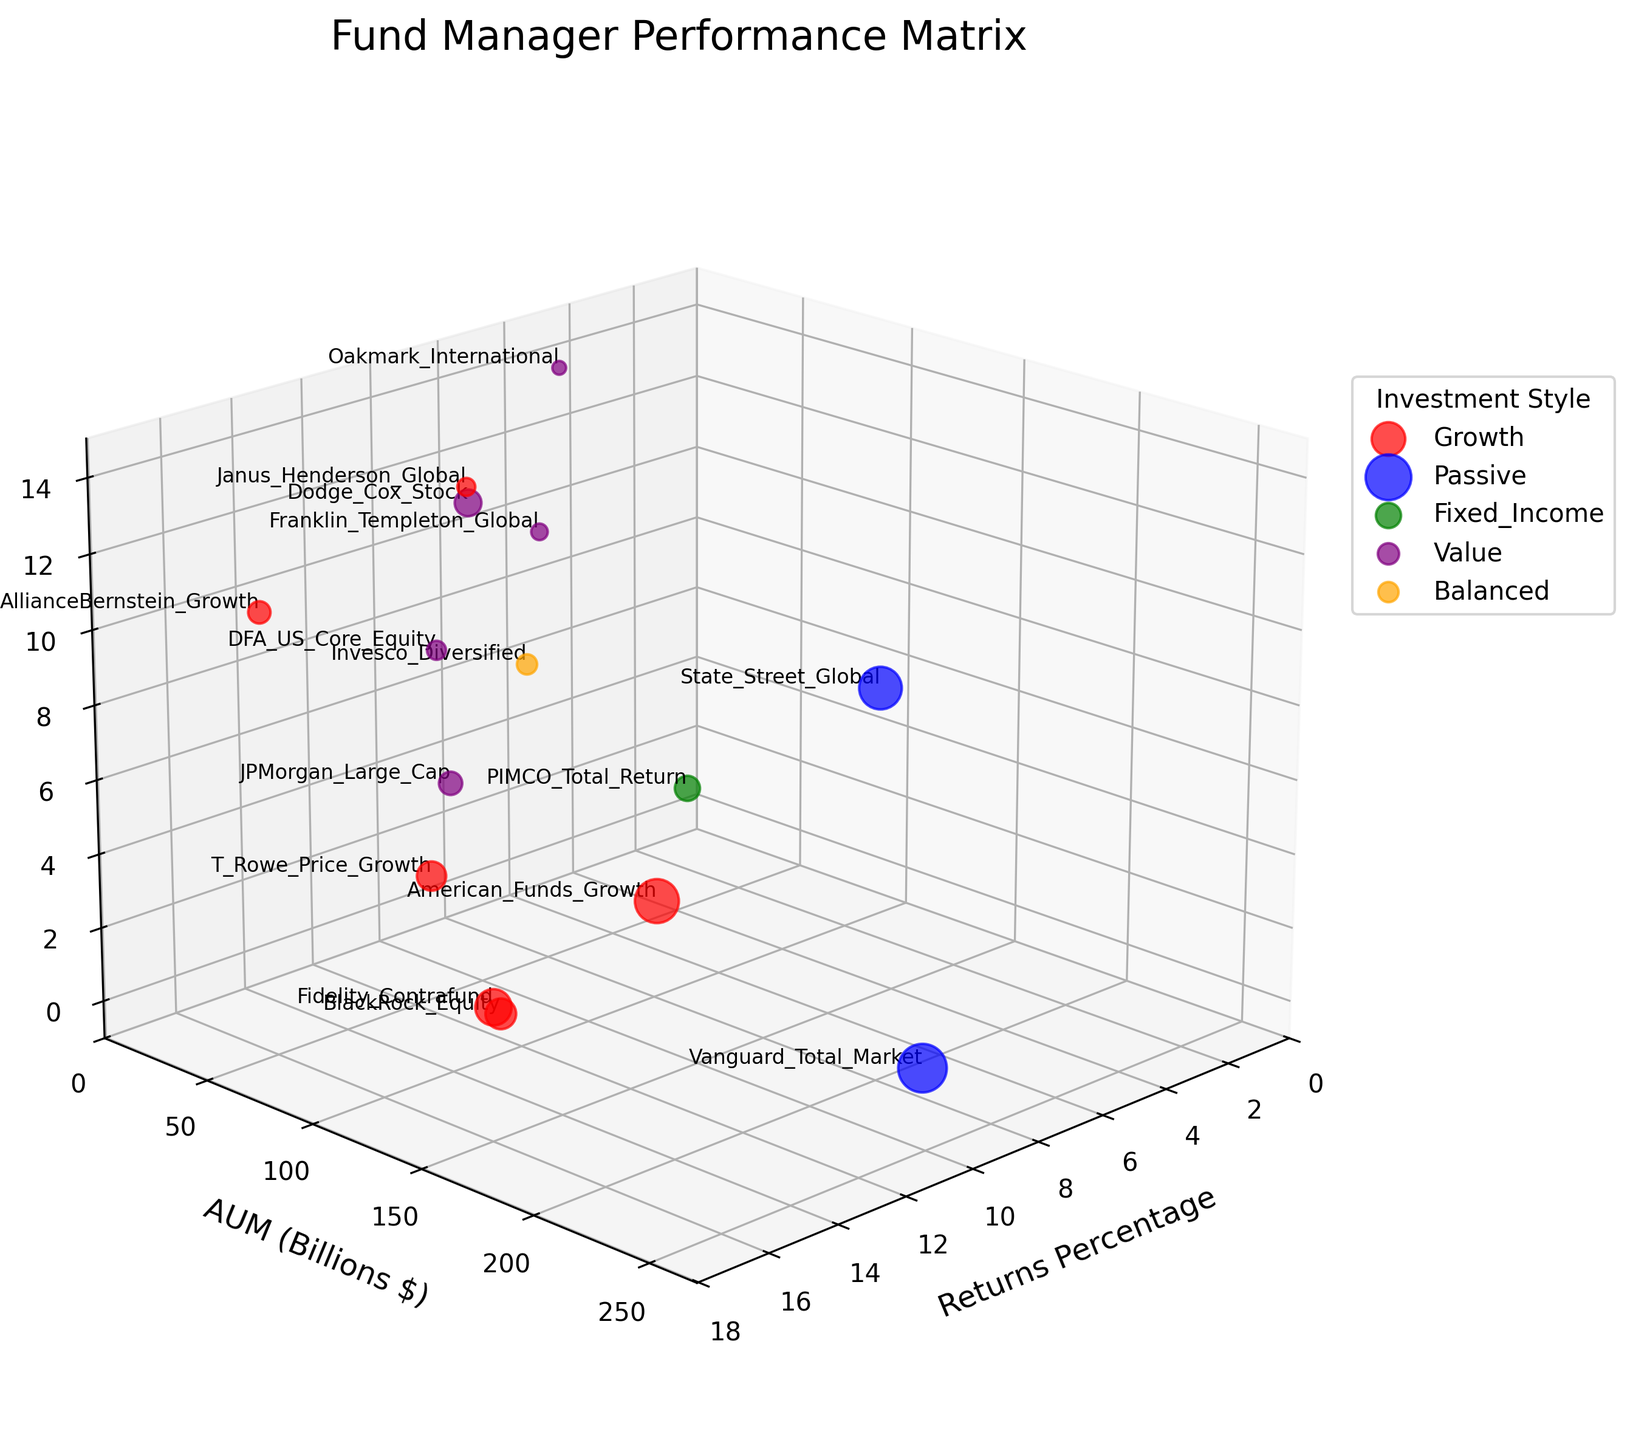What is the title of the figure? The title of the figure is situated at the top, and it summarizes the content of the plot
Answer: Fund Manager Performance Matrix How many fund managers fall under the "Growth" investment style? Count the number of points or labels colored in red in the figure, each representing a "Growth" style fund manager
Answer: 7 Which fund manager has the highest returns percentage? Identify the data point labeled with the highest value on the Returns Percentage axis
Answer: AllianceBernstein_Growth What are the Returns Percentage and AUM (Billions $) for State Street Global? Locate the point labeled "State Street Global" in the figure and read the corresponding values on the Returns Percentage and AUM axes
Answer: Returns: 7.2%, AUM: 189.3 billion $ How many investment styles are represented in the plot? Count the different colors in the legend, which each correspond to a distinct investment style
Answer: 5 Which fund manager has a higher AUM, Vanguard Total Market or BlackRock Equity? Locate the points labeled "Vanguard Total Market" and "BlackRock Equity" and compare their positions on the AUM axis
Answer: Vanguard Total Market What is the combined AUM of the Fixed Income and Balanced investment styles? Sum the AUM values of "PIMCO Total Return" (Fixed Income) and "Invesco Diversified" (Balanced)
Answer: 65.8 + 42.5 = 108.3 billion $ Which investment style includes the fund manager with the lowest returns percentage? Identify the data point with the lowest value on the Returns Percentage axis and check its color for the corresponding investment style
Answer: Fixed_Income (PIMCO Total Return - 4.7%) Among the "Value" investment style fund managers, who has the highest AUM? Compare the AUM values of fund managers labeled with the color representing "Value" and find the one with the highest value
Answer: American_Funds_Growth What are the average returns percentages for Passive and Value investment styles? Calculate the average returns percentage for each investment style by summing up their respective values and then dividing by the number of respective data points
Answer: Passive: (9.8 + 7.2) / 2 = 8.5; Value: (11.3 + 10.5 + 6.8 + 11.8 + 5.6) / 5 = 9.2 